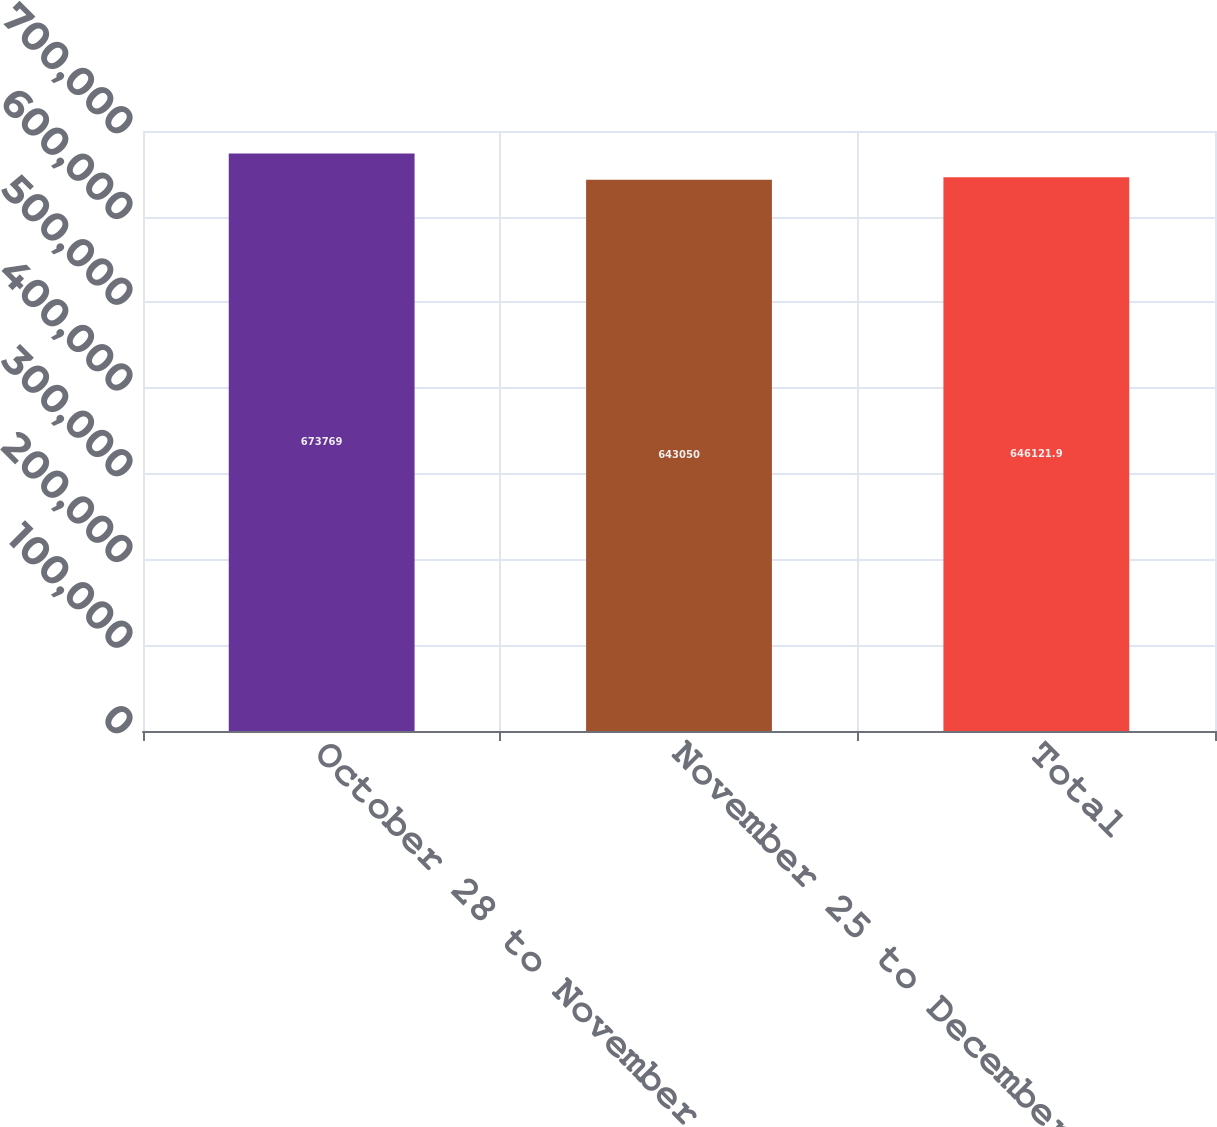Convert chart. <chart><loc_0><loc_0><loc_500><loc_500><bar_chart><fcel>October 28 to November 24 2012<fcel>November 25 to December 31<fcel>Total<nl><fcel>673769<fcel>643050<fcel>646122<nl></chart> 